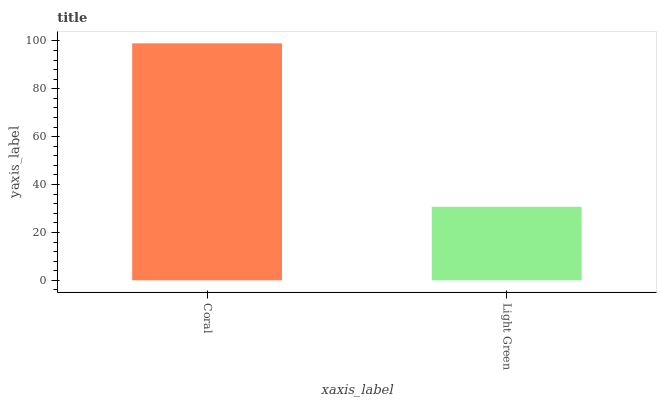Is Light Green the minimum?
Answer yes or no. Yes. Is Coral the maximum?
Answer yes or no. Yes. Is Light Green the maximum?
Answer yes or no. No. Is Coral greater than Light Green?
Answer yes or no. Yes. Is Light Green less than Coral?
Answer yes or no. Yes. Is Light Green greater than Coral?
Answer yes or no. No. Is Coral less than Light Green?
Answer yes or no. No. Is Coral the high median?
Answer yes or no. Yes. Is Light Green the low median?
Answer yes or no. Yes. Is Light Green the high median?
Answer yes or no. No. Is Coral the low median?
Answer yes or no. No. 